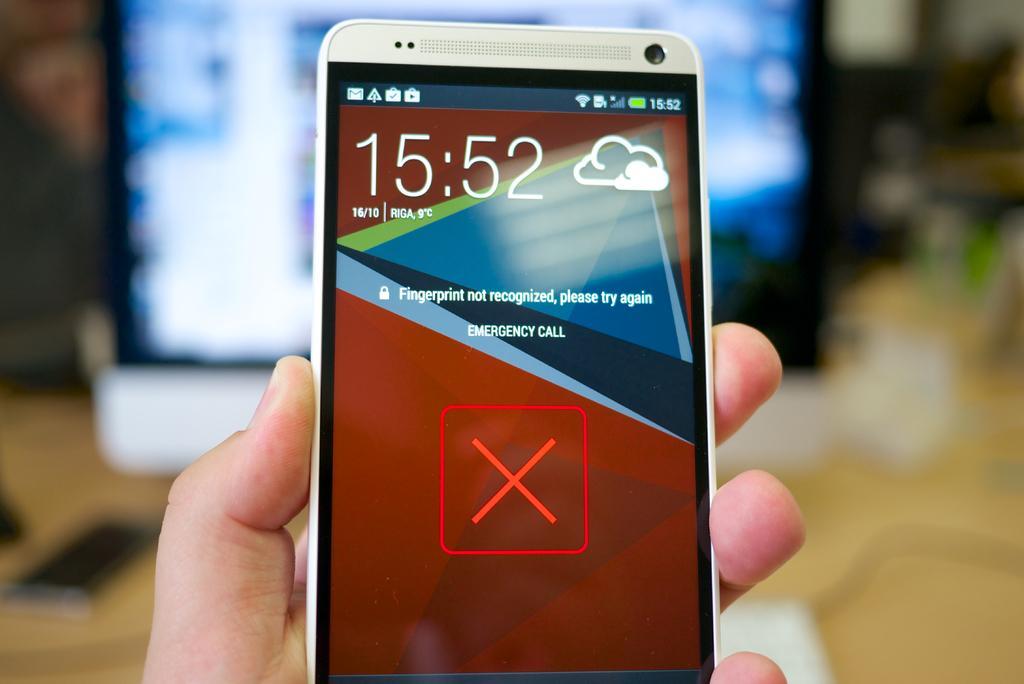Could you give a brief overview of what you see in this image? In this image I can see hand of a person holding a mobile. And the background is blurry. 